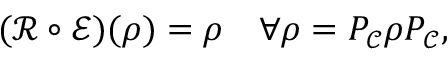Convert formula to latex. <formula><loc_0><loc_0><loc_500><loc_500>( { \mathcal { R } } \circ { \mathcal { E } } ) ( \rho ) = \rho \quad \forall \rho = P _ { \mathcal { C } } \rho P _ { \mathcal { C } } ,</formula> 